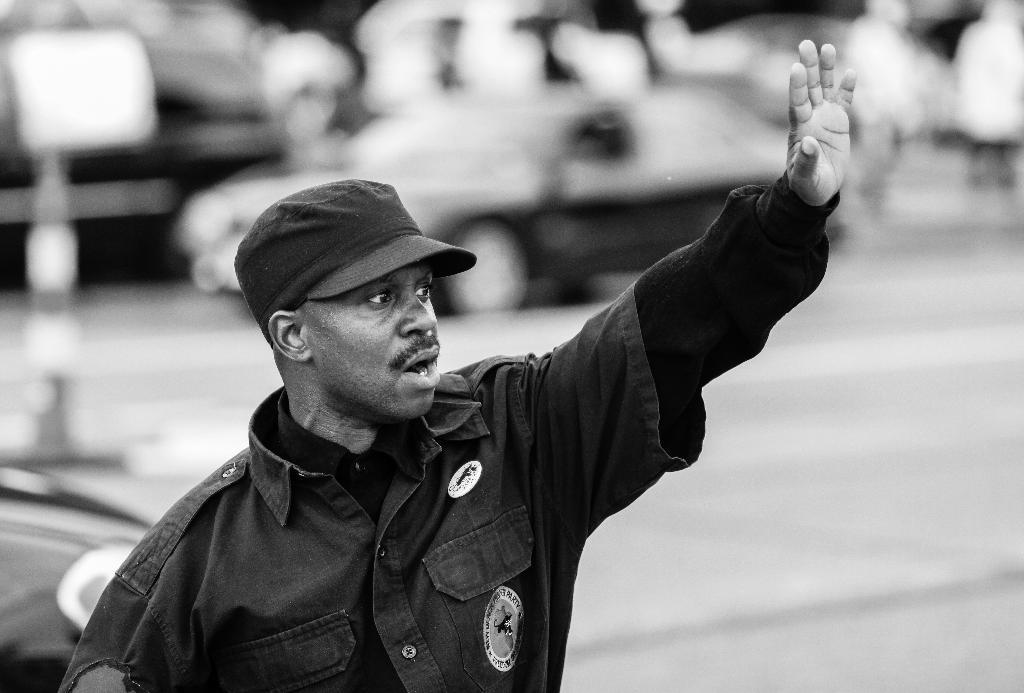What is the color scheme of the image? The image is black and white. Who is present in the image? There is a man in the image. What is the man wearing on his head? The man is wearing a cap. Can you describe the background of the image? The background of the image is blurry. What can be seen in the background of the image? There is a car visible in the background. How does the worm contribute to the quiet atmosphere in the image? There is no worm present in the image, and therefore it cannot contribute to the atmosphere. 